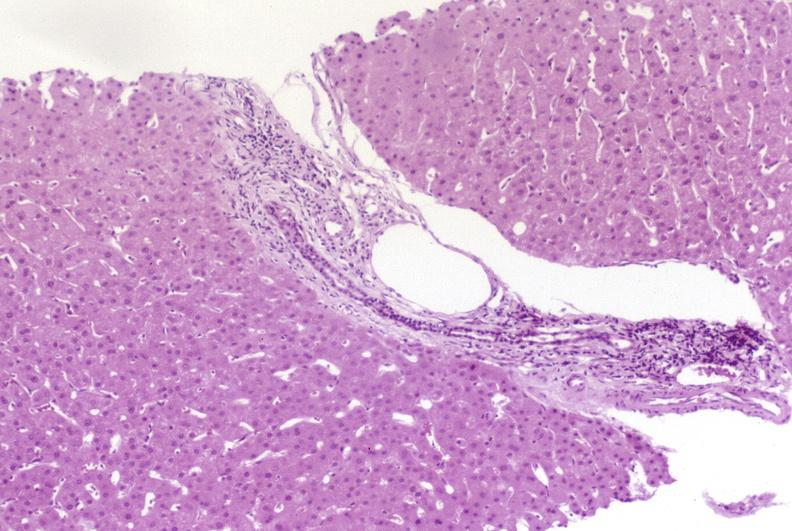does this image show resolving acute rejection?
Answer the question using a single word or phrase. Yes 